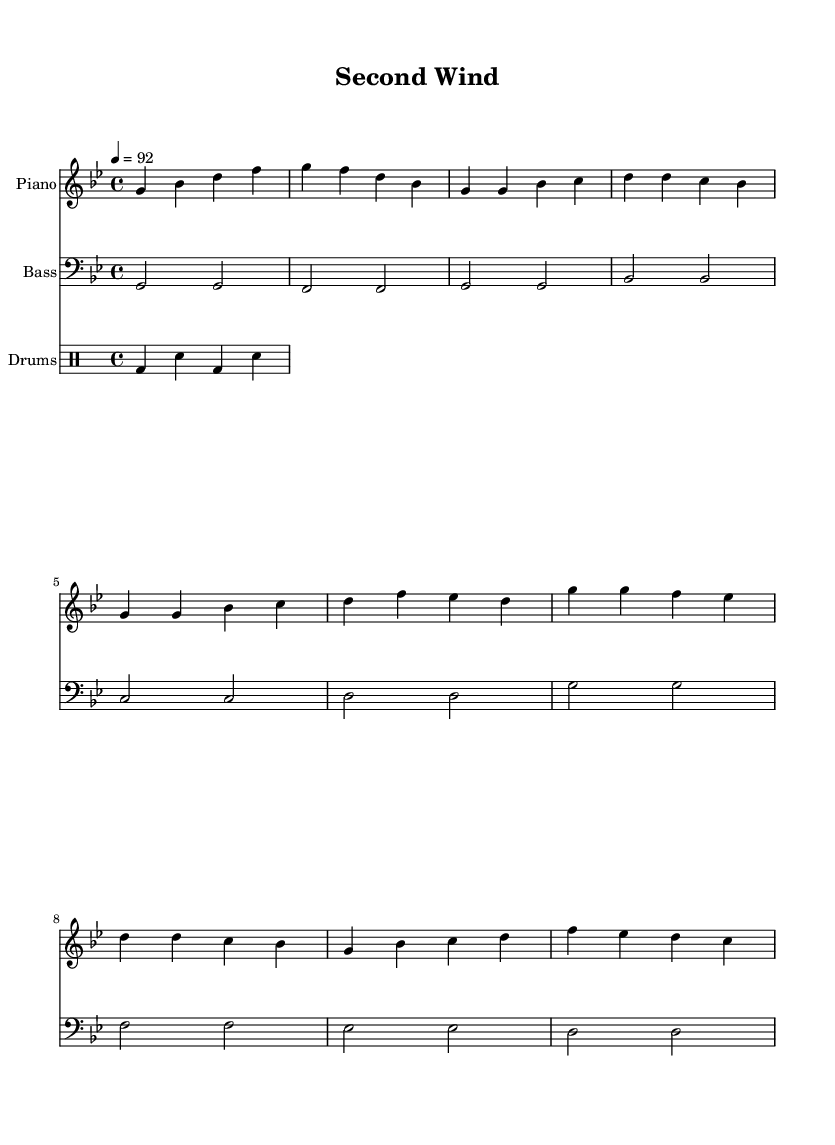What is the key signature of this music? The key signature is indicated at the beginning of the staff. In this case, it shows a B flat and an E flat, which places it in G minor.
Answer: G minor What is the time signature of this music? The time signature is shown right after the key signature, represented as 4/4. This means there are four beats per measure, and the quarter note gets one beat.
Answer: 4/4 What is the tempo marking of the piece? The tempo marking appears under the header and indicates the speed of the piece. Here, the tempo is set to 92 beats per minute, which provides a moderate pace suitable for rap.
Answer: 92 How many measures are there in the verse section? By examining the melody section of the sheet music, you can count the number of measures designated for the verse. There are four measures allocated for the verse lyrics.
Answer: 4 What is the main theme of the lyrics? The lyrics focus on resilience and new beginnings, expressing themes of overcoming challenges and embracing second chances, which is a common theme in motivational hip hop anthems.
Answer: Resilience Which instrument plays the melody primarily? The melody part is indicated in the first staff section at the top, which denotes the piano. This instrument carries the main melodic line of the piece.
Answer: Piano What type of rhythm pattern is used in the drums section? The drum pattern is shown in the drummode section, which consists of a bass drum and snare drum alternating every beat, creating a driving rhythmic foundation typical in rap.
Answer: Alternating 